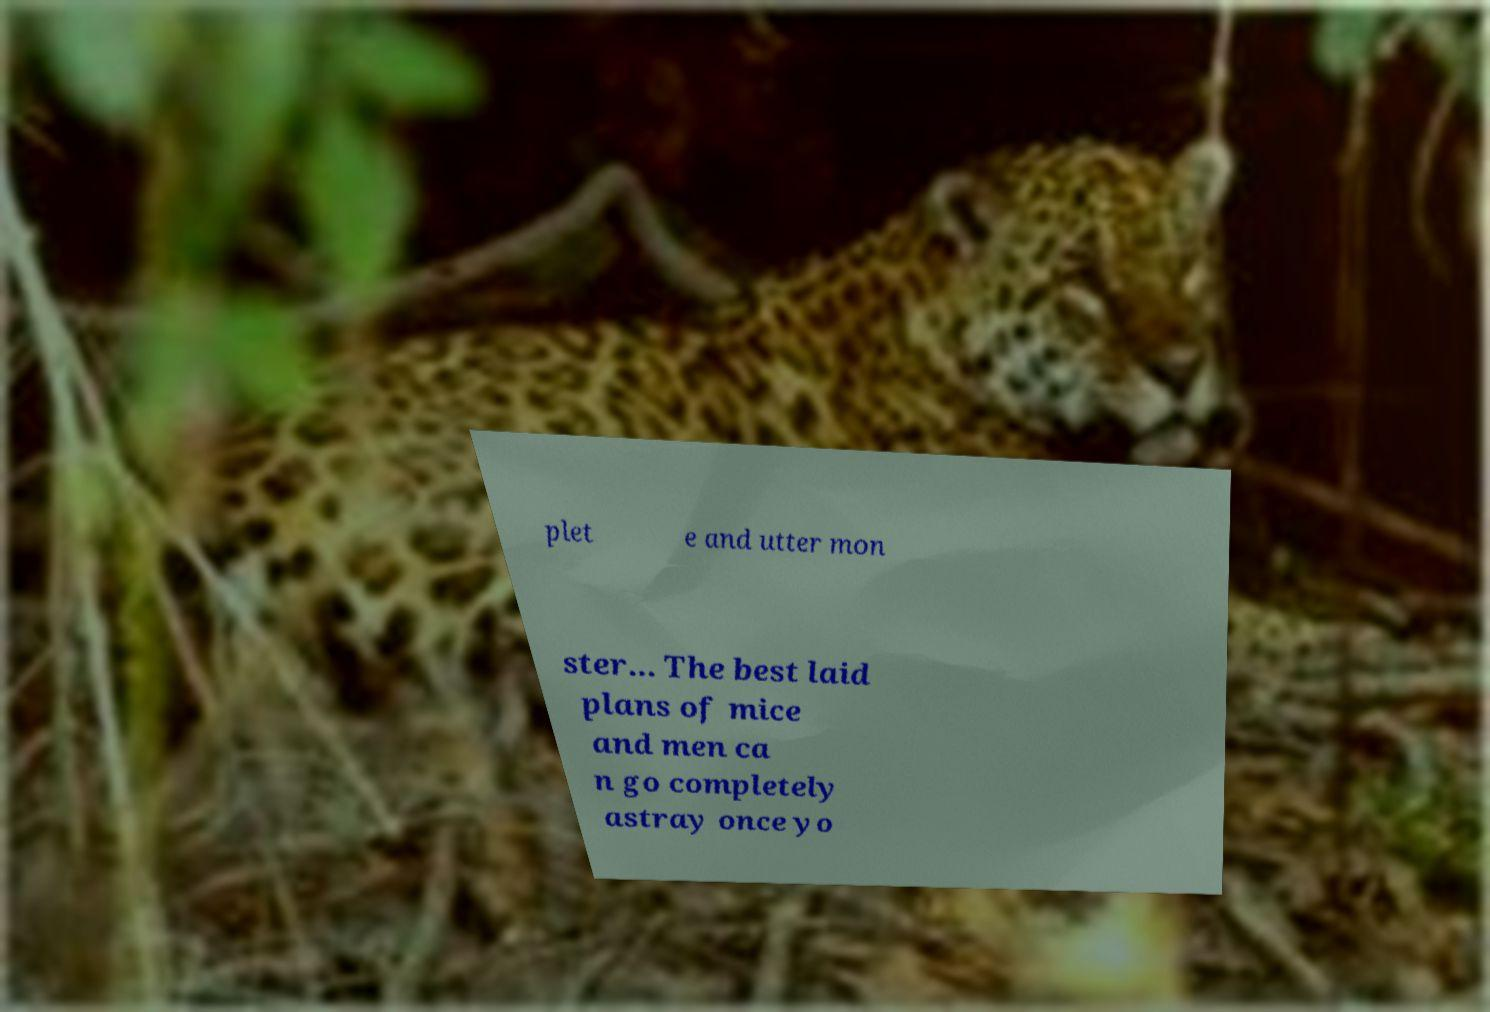For documentation purposes, I need the text within this image transcribed. Could you provide that? plet e and utter mon ster... The best laid plans of mice and men ca n go completely astray once yo 